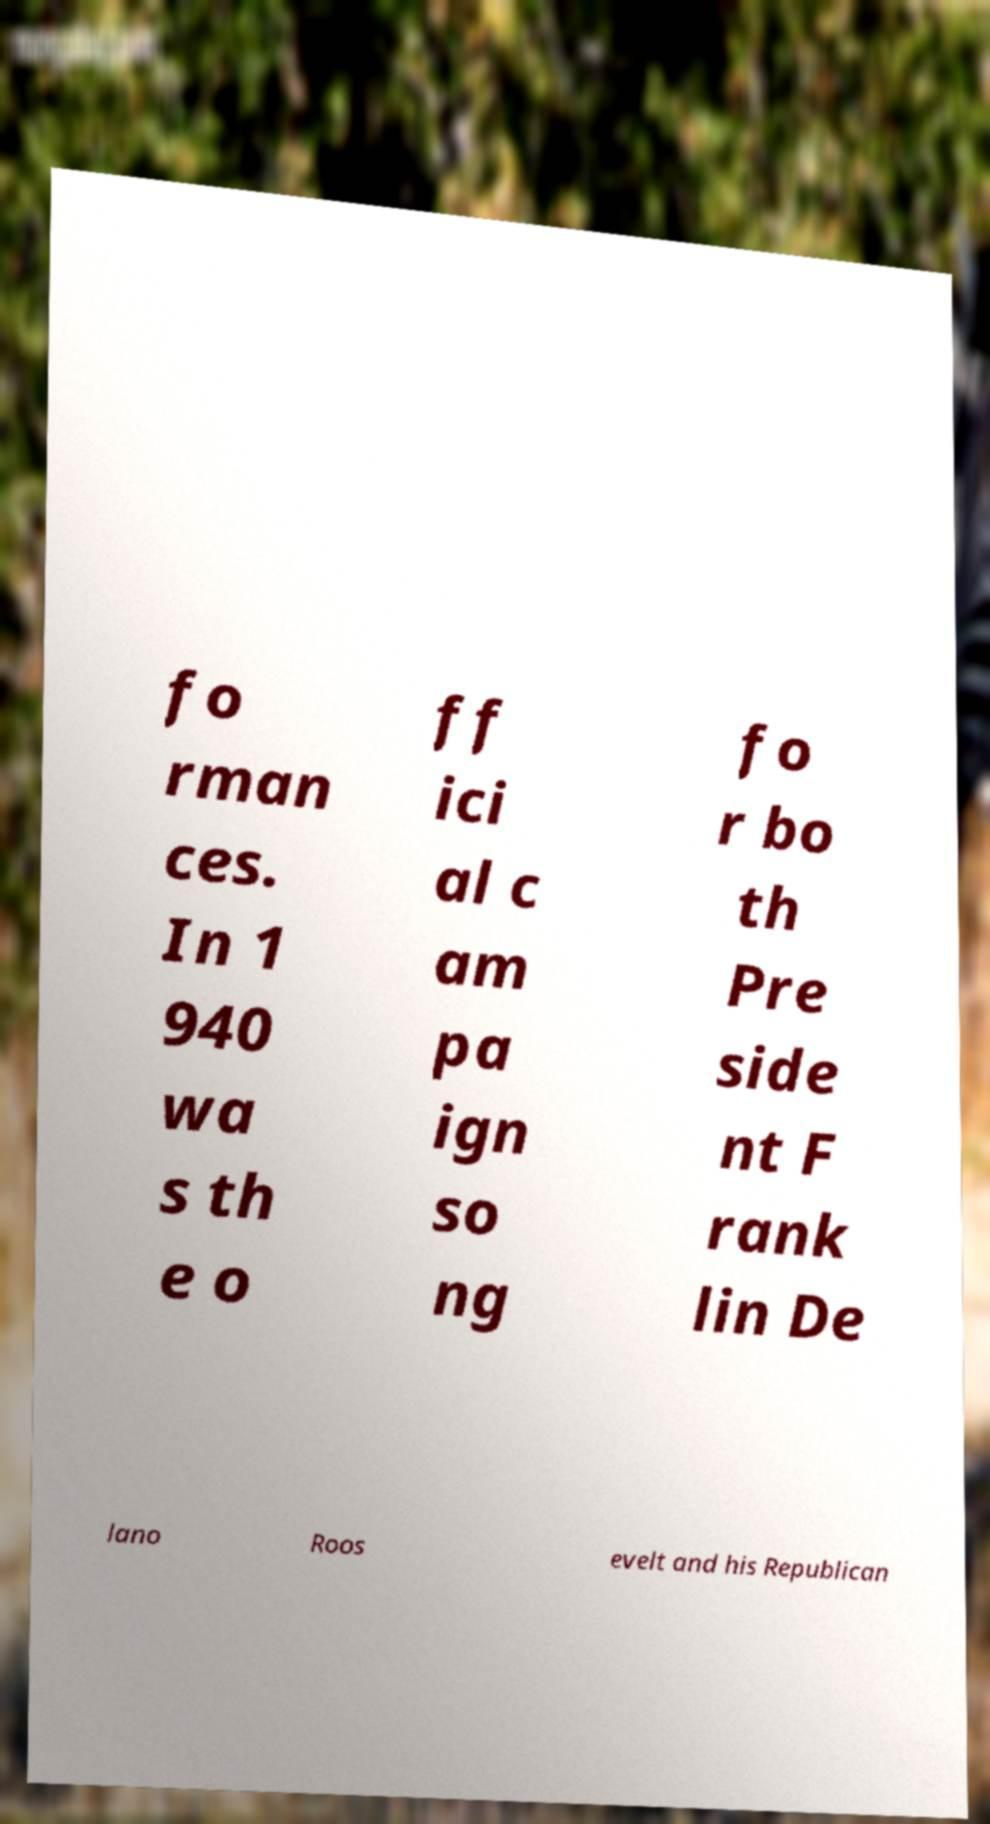There's text embedded in this image that I need extracted. Can you transcribe it verbatim? fo rman ces. In 1 940 wa s th e o ff ici al c am pa ign so ng fo r bo th Pre side nt F rank lin De lano Roos evelt and his Republican 